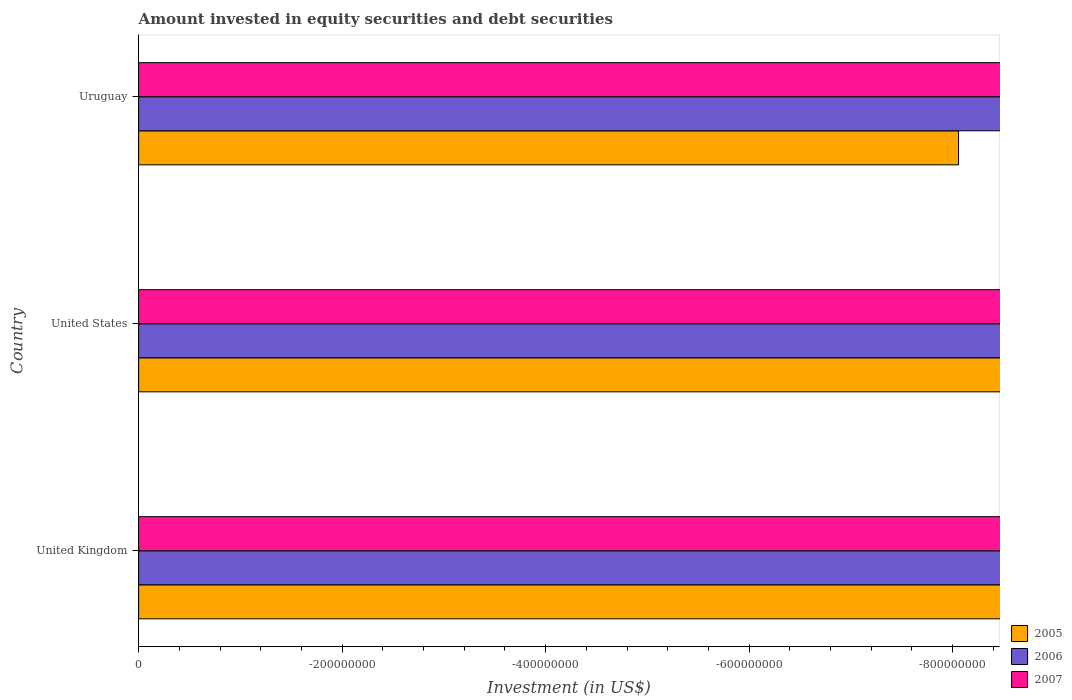How many different coloured bars are there?
Your answer should be very brief. 0. Are the number of bars on each tick of the Y-axis equal?
Ensure brevity in your answer.  Yes. How many bars are there on the 3rd tick from the top?
Provide a succinct answer. 0. What is the label of the 1st group of bars from the top?
Offer a terse response. Uruguay. Across all countries, what is the minimum amount invested in equity securities and debt securities in 2006?
Give a very brief answer. 0. What is the difference between the amount invested in equity securities and debt securities in 2005 in United Kingdom and the amount invested in equity securities and debt securities in 2006 in Uruguay?
Give a very brief answer. 0. What is the average amount invested in equity securities and debt securities in 2006 per country?
Keep it short and to the point. 0. In how many countries, is the amount invested in equity securities and debt securities in 2006 greater than -400000000 US$?
Provide a short and direct response. 0. Is it the case that in every country, the sum of the amount invested in equity securities and debt securities in 2007 and amount invested in equity securities and debt securities in 2006 is greater than the amount invested in equity securities and debt securities in 2005?
Provide a short and direct response. No. What is the difference between two consecutive major ticks on the X-axis?
Your response must be concise. 2.00e+08. Where does the legend appear in the graph?
Give a very brief answer. Bottom right. What is the title of the graph?
Your response must be concise. Amount invested in equity securities and debt securities. Does "1980" appear as one of the legend labels in the graph?
Make the answer very short. No. What is the label or title of the X-axis?
Make the answer very short. Investment (in US$). What is the Investment (in US$) of 2005 in United Kingdom?
Offer a terse response. 0. What is the Investment (in US$) in 2006 in United Kingdom?
Offer a very short reply. 0. What is the Investment (in US$) in 2005 in United States?
Your response must be concise. 0. What is the Investment (in US$) in 2006 in United States?
Offer a terse response. 0. What is the Investment (in US$) of 2005 in Uruguay?
Provide a succinct answer. 0. What is the Investment (in US$) of 2006 in Uruguay?
Your answer should be very brief. 0. What is the total Investment (in US$) in 2005 in the graph?
Your response must be concise. 0. What is the total Investment (in US$) of 2006 in the graph?
Your answer should be very brief. 0. What is the average Investment (in US$) in 2006 per country?
Provide a short and direct response. 0. 